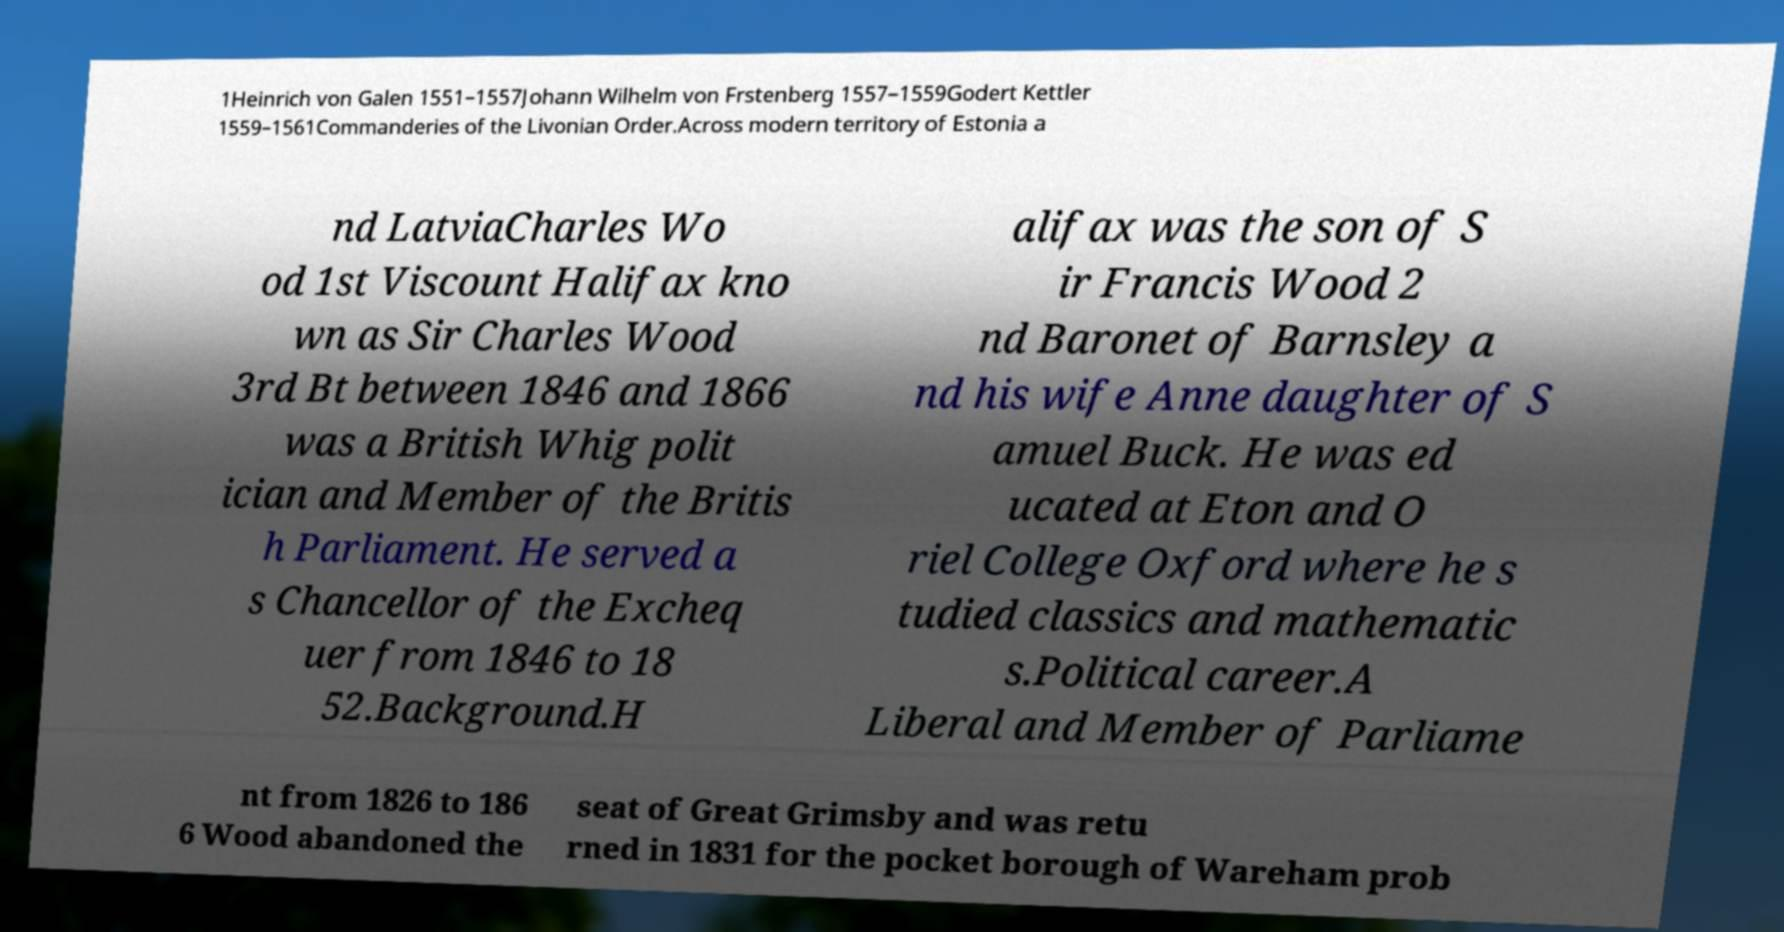Please identify and transcribe the text found in this image. 1Heinrich von Galen 1551–1557Johann Wilhelm von Frstenberg 1557–1559Godert Kettler 1559–1561Commanderies of the Livonian Order.Across modern territory of Estonia a nd LatviaCharles Wo od 1st Viscount Halifax kno wn as Sir Charles Wood 3rd Bt between 1846 and 1866 was a British Whig polit ician and Member of the Britis h Parliament. He served a s Chancellor of the Excheq uer from 1846 to 18 52.Background.H alifax was the son of S ir Francis Wood 2 nd Baronet of Barnsley a nd his wife Anne daughter of S amuel Buck. He was ed ucated at Eton and O riel College Oxford where he s tudied classics and mathematic s.Political career.A Liberal and Member of Parliame nt from 1826 to 186 6 Wood abandoned the seat of Great Grimsby and was retu rned in 1831 for the pocket borough of Wareham prob 